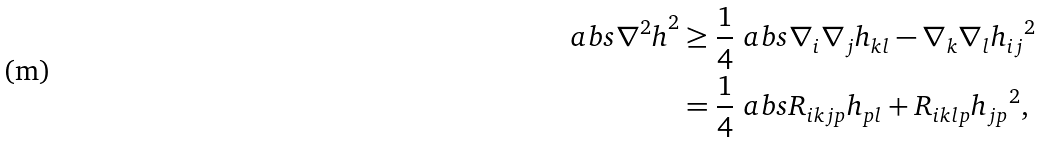Convert formula to latex. <formula><loc_0><loc_0><loc_500><loc_500>\ a b s { \nabla ^ { 2 } h } ^ { 2 } & \geq \frac { 1 } { 4 } \ a b s { \nabla _ { i } \nabla _ { j } h _ { k l } - \nabla _ { k } \nabla _ { l } h _ { i j } } ^ { 2 } \\ & = \frac { 1 } { 4 } \ a b s { R _ { i k j p } h _ { p l } + R _ { i k l p } h _ { j p } } ^ { 2 } ,</formula> 